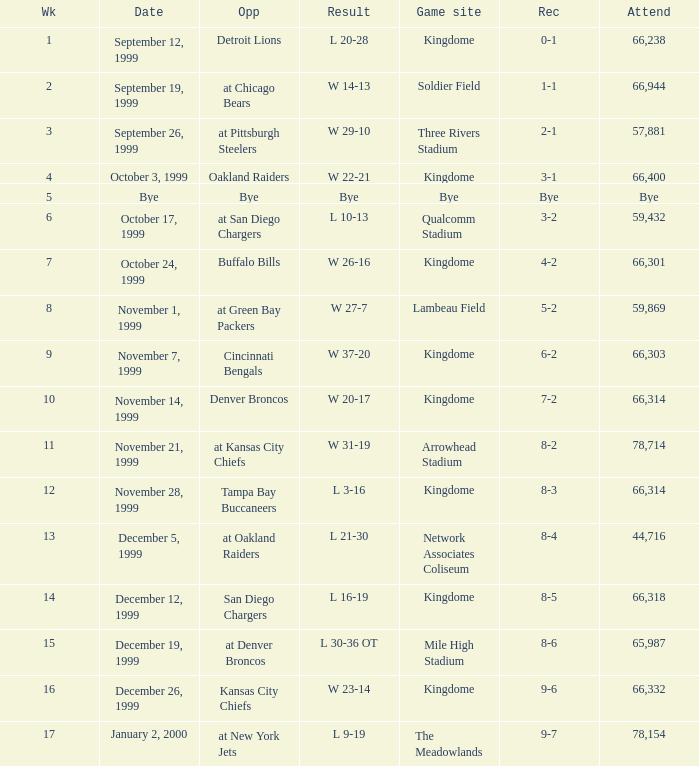Could you parse the entire table? {'header': ['Wk', 'Date', 'Opp', 'Result', 'Game site', 'Rec', 'Attend'], 'rows': [['1', 'September 12, 1999', 'Detroit Lions', 'L 20-28', 'Kingdome', '0-1', '66,238'], ['2', 'September 19, 1999', 'at Chicago Bears', 'W 14-13', 'Soldier Field', '1-1', '66,944'], ['3', 'September 26, 1999', 'at Pittsburgh Steelers', 'W 29-10', 'Three Rivers Stadium', '2-1', '57,881'], ['4', 'October 3, 1999', 'Oakland Raiders', 'W 22-21', 'Kingdome', '3-1', '66,400'], ['5', 'Bye', 'Bye', 'Bye', 'Bye', 'Bye', 'Bye'], ['6', 'October 17, 1999', 'at San Diego Chargers', 'L 10-13', 'Qualcomm Stadium', '3-2', '59,432'], ['7', 'October 24, 1999', 'Buffalo Bills', 'W 26-16', 'Kingdome', '4-2', '66,301'], ['8', 'November 1, 1999', 'at Green Bay Packers', 'W 27-7', 'Lambeau Field', '5-2', '59,869'], ['9', 'November 7, 1999', 'Cincinnati Bengals', 'W 37-20', 'Kingdome', '6-2', '66,303'], ['10', 'November 14, 1999', 'Denver Broncos', 'W 20-17', 'Kingdome', '7-2', '66,314'], ['11', 'November 21, 1999', 'at Kansas City Chiefs', 'W 31-19', 'Arrowhead Stadium', '8-2', '78,714'], ['12', 'November 28, 1999', 'Tampa Bay Buccaneers', 'L 3-16', 'Kingdome', '8-3', '66,314'], ['13', 'December 5, 1999', 'at Oakland Raiders', 'L 21-30', 'Network Associates Coliseum', '8-4', '44,716'], ['14', 'December 12, 1999', 'San Diego Chargers', 'L 16-19', 'Kingdome', '8-5', '66,318'], ['15', 'December 19, 1999', 'at Denver Broncos', 'L 30-36 OT', 'Mile High Stadium', '8-6', '65,987'], ['16', 'December 26, 1999', 'Kansas City Chiefs', 'W 23-14', 'Kingdome', '9-6', '66,332'], ['17', 'January 2, 2000', 'at New York Jets', 'L 9-19', 'The Meadowlands', '9-7', '78,154']]} What was the result of the game that was played on week 15? L 30-36 OT. 